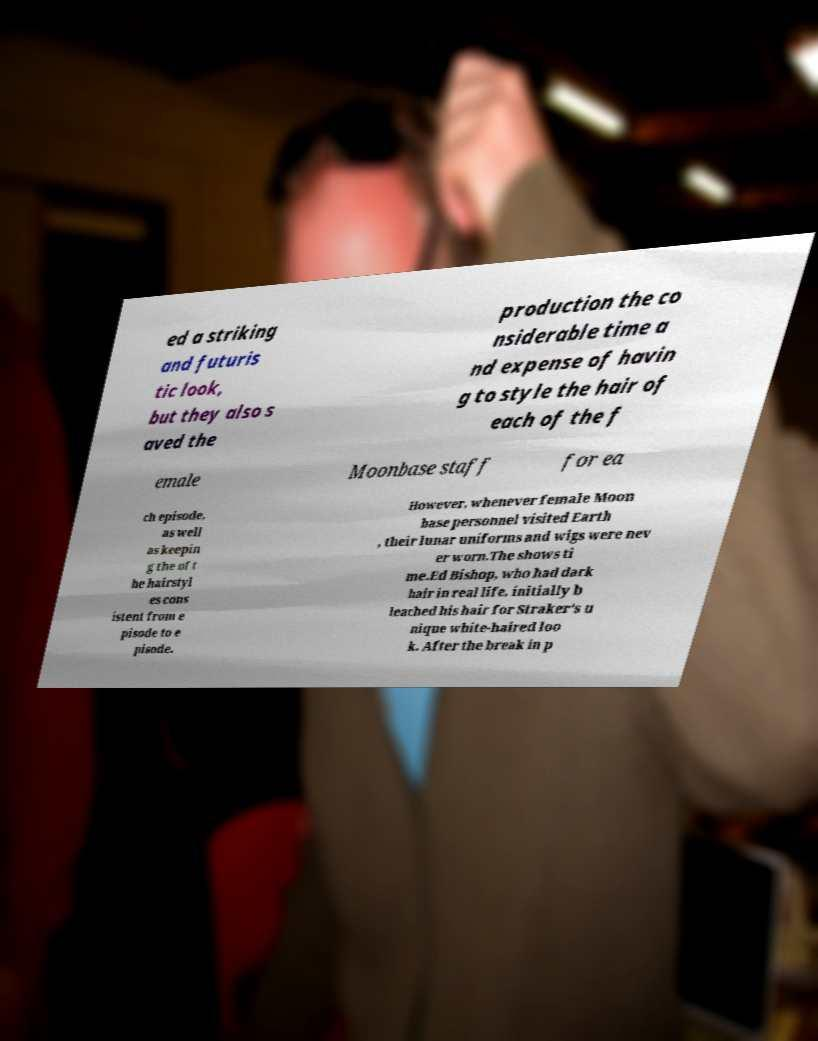Can you read and provide the text displayed in the image?This photo seems to have some interesting text. Can you extract and type it out for me? ed a striking and futuris tic look, but they also s aved the production the co nsiderable time a nd expense of havin g to style the hair of each of the f emale Moonbase staff for ea ch episode, as well as keepin g the of t he hairstyl es cons istent from e pisode to e pisode. However, whenever female Moon base personnel visited Earth , their lunar uniforms and wigs were nev er worn.The shows ti me.Ed Bishop, who had dark hair in real life, initially b leached his hair for Straker's u nique white-haired loo k. After the break in p 